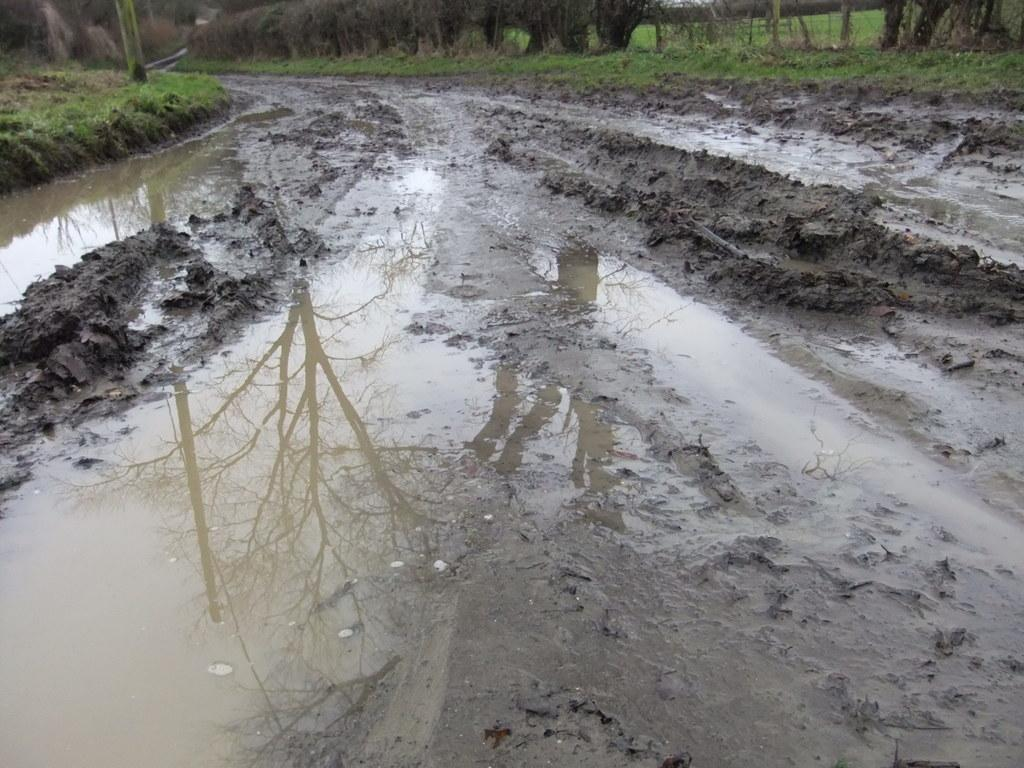What type of surface is visible in the image? There is soil visible in the image. What is present on the soil in the image? There is water on the soil. What type of vegetation can be seen at the top of the image? Trees are visible at the top of the image. What type of cable is being used by the queen in the image? There is no queen or cable present in the image. What type of competition is taking place in the image? There is no competition present in the image. 